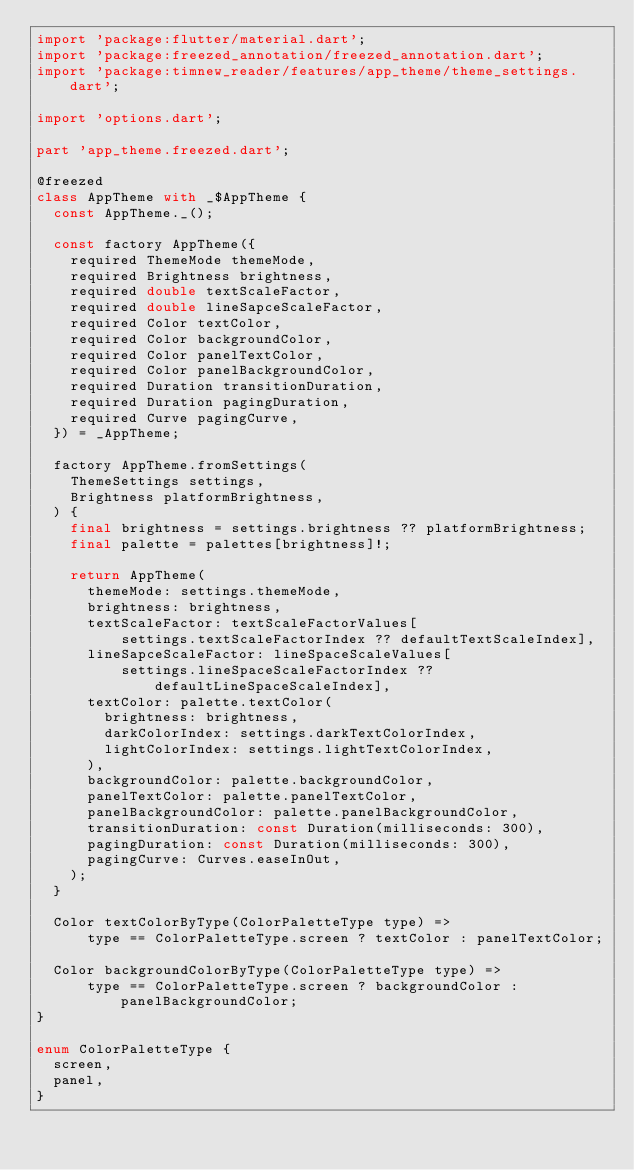Convert code to text. <code><loc_0><loc_0><loc_500><loc_500><_Dart_>import 'package:flutter/material.dart';
import 'package:freezed_annotation/freezed_annotation.dart';
import 'package:timnew_reader/features/app_theme/theme_settings.dart';

import 'options.dart';

part 'app_theme.freezed.dart';

@freezed
class AppTheme with _$AppTheme {
  const AppTheme._();

  const factory AppTheme({
    required ThemeMode themeMode,
    required Brightness brightness,
    required double textScaleFactor,
    required double lineSapceScaleFactor,
    required Color textColor,
    required Color backgroundColor,
    required Color panelTextColor,
    required Color panelBackgroundColor,
    required Duration transitionDuration,
    required Duration pagingDuration,
    required Curve pagingCurve,
  }) = _AppTheme;

  factory AppTheme.fromSettings(
    ThemeSettings settings,
    Brightness platformBrightness,
  ) {
    final brightness = settings.brightness ?? platformBrightness;
    final palette = palettes[brightness]!;

    return AppTheme(
      themeMode: settings.themeMode,
      brightness: brightness,
      textScaleFactor: textScaleFactorValues[
          settings.textScaleFactorIndex ?? defaultTextScaleIndex],
      lineSapceScaleFactor: lineSpaceScaleValues[
          settings.lineSpaceScaleFactorIndex ?? defaultLineSpaceScaleIndex],
      textColor: palette.textColor(
        brightness: brightness,
        darkColorIndex: settings.darkTextColorIndex,
        lightColorIndex: settings.lightTextColorIndex,
      ),
      backgroundColor: palette.backgroundColor,
      panelTextColor: palette.panelTextColor,
      panelBackgroundColor: palette.panelBackgroundColor,
      transitionDuration: const Duration(milliseconds: 300),
      pagingDuration: const Duration(milliseconds: 300),
      pagingCurve: Curves.easeInOut,
    );
  }

  Color textColorByType(ColorPaletteType type) =>
      type == ColorPaletteType.screen ? textColor : panelTextColor;

  Color backgroundColorByType(ColorPaletteType type) =>
      type == ColorPaletteType.screen ? backgroundColor : panelBackgroundColor;
}

enum ColorPaletteType {
  screen,
  panel,
}
</code> 